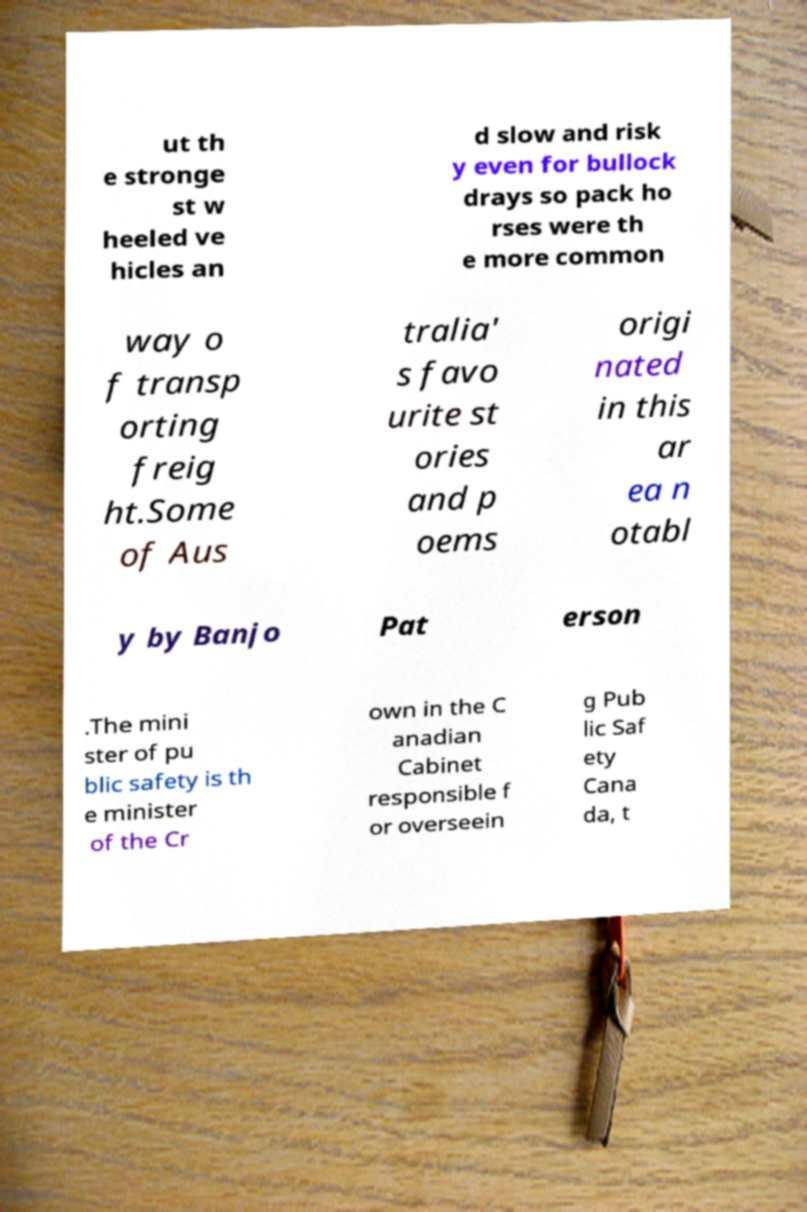Please identify and transcribe the text found in this image. ut th e stronge st w heeled ve hicles an d slow and risk y even for bullock drays so pack ho rses were th e more common way o f transp orting freig ht.Some of Aus tralia' s favo urite st ories and p oems origi nated in this ar ea n otabl y by Banjo Pat erson .The mini ster of pu blic safety is th e minister of the Cr own in the C anadian Cabinet responsible f or overseein g Pub lic Saf ety Cana da, t 